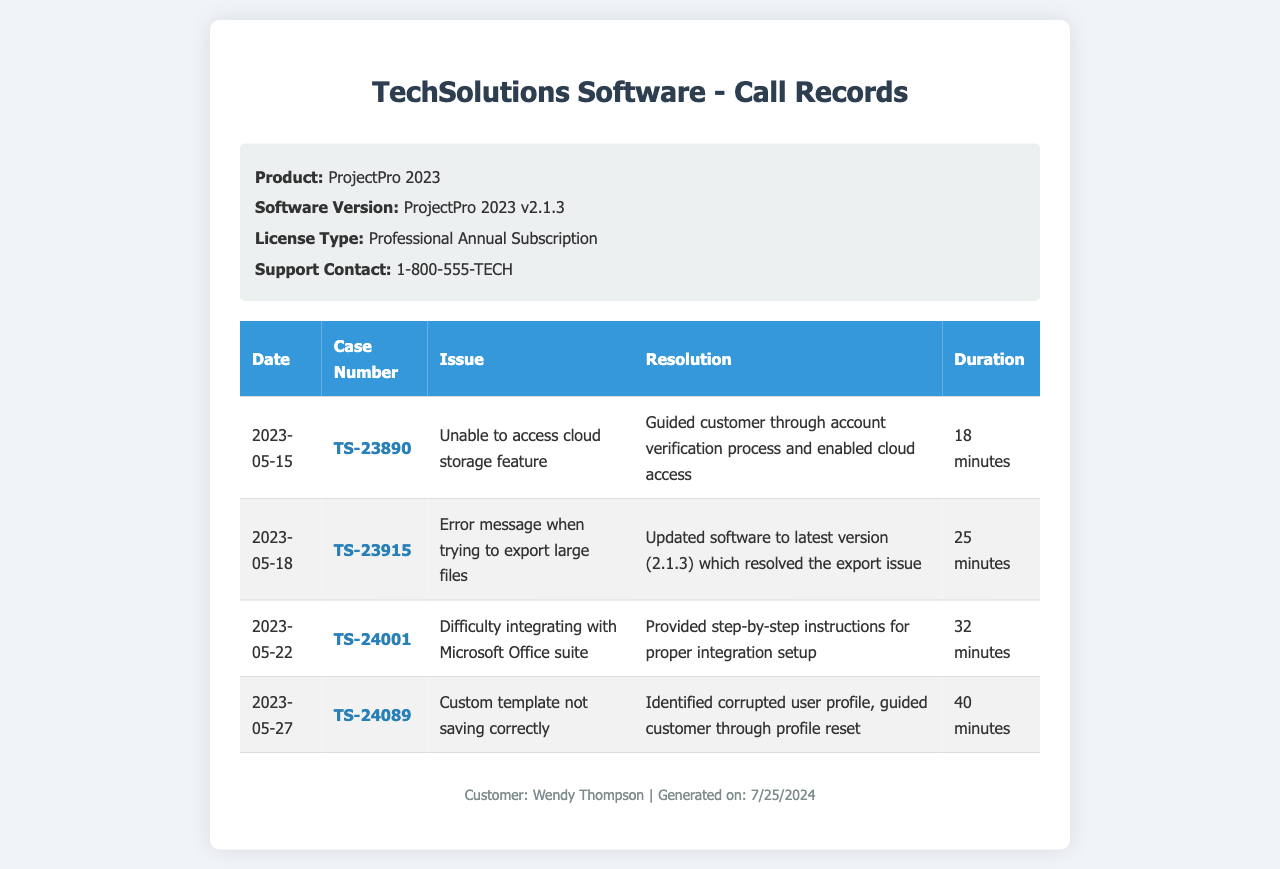What is the software version? The software version listed in the document is ProjectPro 2023 v2.1.3.
Answer: ProjectPro 2023 v2.1.3 What is the first case number? The first case number in the records is TS-23890, which appears in the first row of the table.
Answer: TS-23890 How long did the call regarding cloud storage take? The duration of the call regarding the cloud storage issue is 18 minutes, as stated in the table.
Answer: 18 minutes What issue was reported on May 22? The document states that the issue reported on May 22 is related to difficulty integrating with Microsoft Office suite.
Answer: Difficulty integrating with Microsoft Office suite How many issues are listed in the records? The total number of issues listed in the records can be counted from the table, which contains four entries.
Answer: 4 What was the resolution for case TS-23915? The resolution for case TS-23915 involved updating the software to the latest version, which resolved the export issue.
Answer: Updated software to latest version What is the support contact number? The support contact number provided in the document is 1-800-555-TECH.
Answer: 1-800-555-TECH What issue involved a corrupted user profile? The issue that involved a corrupted user profile is related to a custom template not saving correctly.
Answer: Custom template not saving correctly What is the date of the last recorded call? The date of the last recorded call listed in the document is 2023-05-27.
Answer: 2023-05-27 